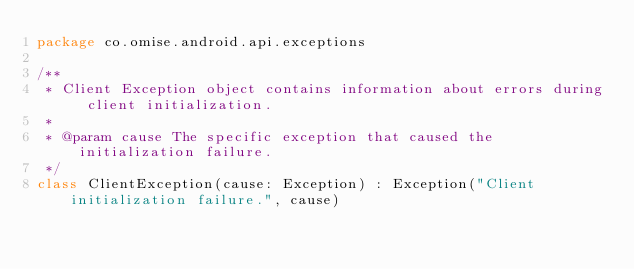Convert code to text. <code><loc_0><loc_0><loc_500><loc_500><_Kotlin_>package co.omise.android.api.exceptions

/**
 * Client Exception object contains information about errors during client initialization.
 *
 * @param cause The specific exception that caused the initialization failure.
 */
class ClientException(cause: Exception) : Exception("Client initialization failure.", cause)
</code> 